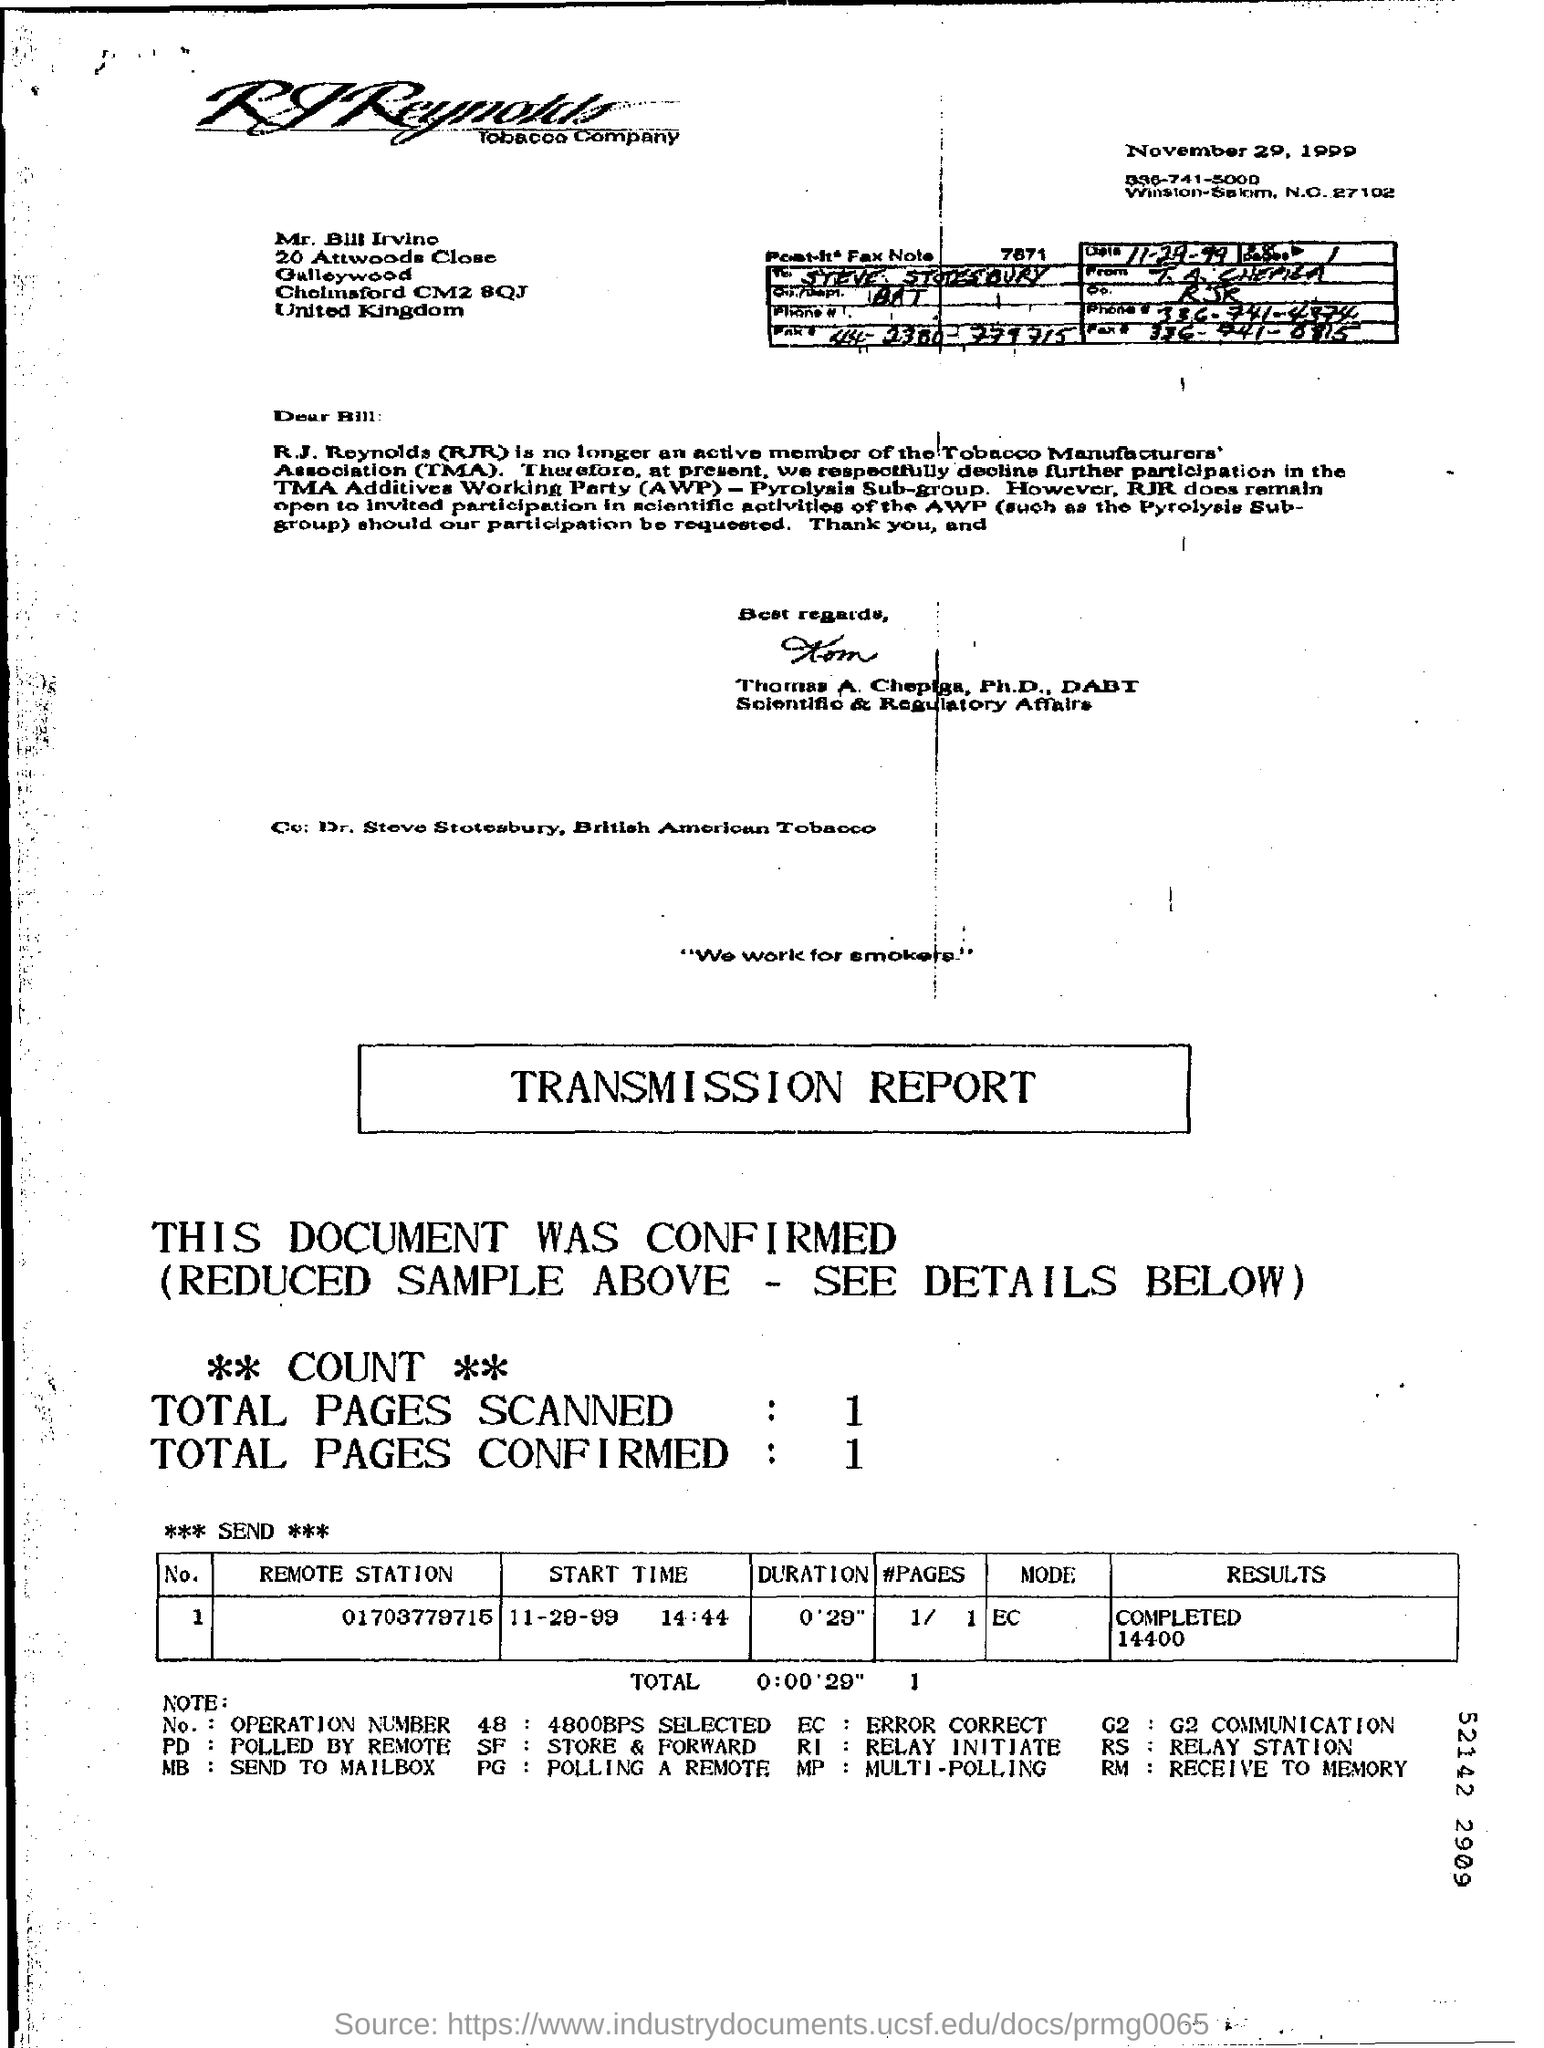Point out several critical features in this image. This transmission report is a document. The date mentioned at the top of the document is November 29, 1999. 